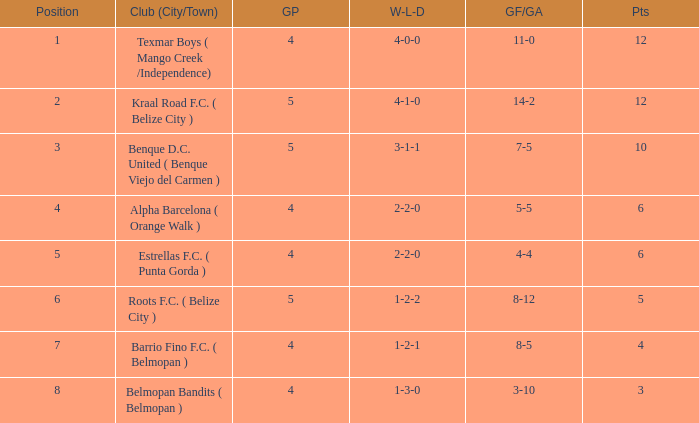What's the w-l-d with position being 1 4-0-0. 